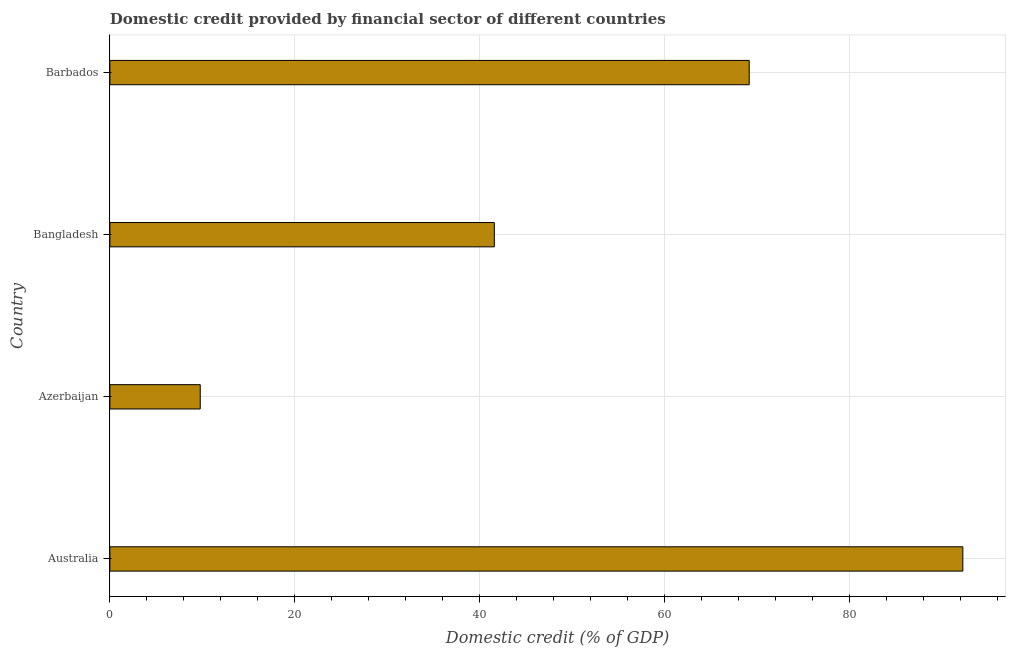What is the title of the graph?
Provide a succinct answer. Domestic credit provided by financial sector of different countries. What is the label or title of the X-axis?
Provide a succinct answer. Domestic credit (% of GDP). What is the label or title of the Y-axis?
Your answer should be very brief. Country. What is the domestic credit provided by financial sector in Australia?
Offer a terse response. 92.25. Across all countries, what is the maximum domestic credit provided by financial sector?
Keep it short and to the point. 92.25. Across all countries, what is the minimum domestic credit provided by financial sector?
Keep it short and to the point. 9.77. In which country was the domestic credit provided by financial sector minimum?
Provide a short and direct response. Azerbaijan. What is the sum of the domestic credit provided by financial sector?
Make the answer very short. 212.75. What is the difference between the domestic credit provided by financial sector in Bangladesh and Barbados?
Offer a terse response. -27.57. What is the average domestic credit provided by financial sector per country?
Your answer should be compact. 53.19. What is the median domestic credit provided by financial sector?
Your response must be concise. 55.36. What is the ratio of the domestic credit provided by financial sector in Australia to that in Azerbaijan?
Provide a short and direct response. 9.44. Is the difference between the domestic credit provided by financial sector in Australia and Azerbaijan greater than the difference between any two countries?
Make the answer very short. Yes. What is the difference between the highest and the second highest domestic credit provided by financial sector?
Keep it short and to the point. 23.11. What is the difference between the highest and the lowest domestic credit provided by financial sector?
Give a very brief answer. 82.48. Are all the bars in the graph horizontal?
Offer a terse response. Yes. Are the values on the major ticks of X-axis written in scientific E-notation?
Your response must be concise. No. What is the Domestic credit (% of GDP) of Australia?
Provide a succinct answer. 92.25. What is the Domestic credit (% of GDP) in Azerbaijan?
Keep it short and to the point. 9.77. What is the Domestic credit (% of GDP) of Bangladesh?
Offer a terse response. 41.58. What is the Domestic credit (% of GDP) in Barbados?
Make the answer very short. 69.15. What is the difference between the Domestic credit (% of GDP) in Australia and Azerbaijan?
Your answer should be compact. 82.48. What is the difference between the Domestic credit (% of GDP) in Australia and Bangladesh?
Give a very brief answer. 50.67. What is the difference between the Domestic credit (% of GDP) in Australia and Barbados?
Your answer should be very brief. 23.11. What is the difference between the Domestic credit (% of GDP) in Azerbaijan and Bangladesh?
Offer a very short reply. -31.81. What is the difference between the Domestic credit (% of GDP) in Azerbaijan and Barbados?
Your answer should be very brief. -59.37. What is the difference between the Domestic credit (% of GDP) in Bangladesh and Barbados?
Your answer should be compact. -27.57. What is the ratio of the Domestic credit (% of GDP) in Australia to that in Azerbaijan?
Your answer should be compact. 9.44. What is the ratio of the Domestic credit (% of GDP) in Australia to that in Bangladesh?
Provide a short and direct response. 2.22. What is the ratio of the Domestic credit (% of GDP) in Australia to that in Barbados?
Your answer should be very brief. 1.33. What is the ratio of the Domestic credit (% of GDP) in Azerbaijan to that in Bangladesh?
Offer a very short reply. 0.23. What is the ratio of the Domestic credit (% of GDP) in Azerbaijan to that in Barbados?
Your response must be concise. 0.14. What is the ratio of the Domestic credit (% of GDP) in Bangladesh to that in Barbados?
Give a very brief answer. 0.6. 